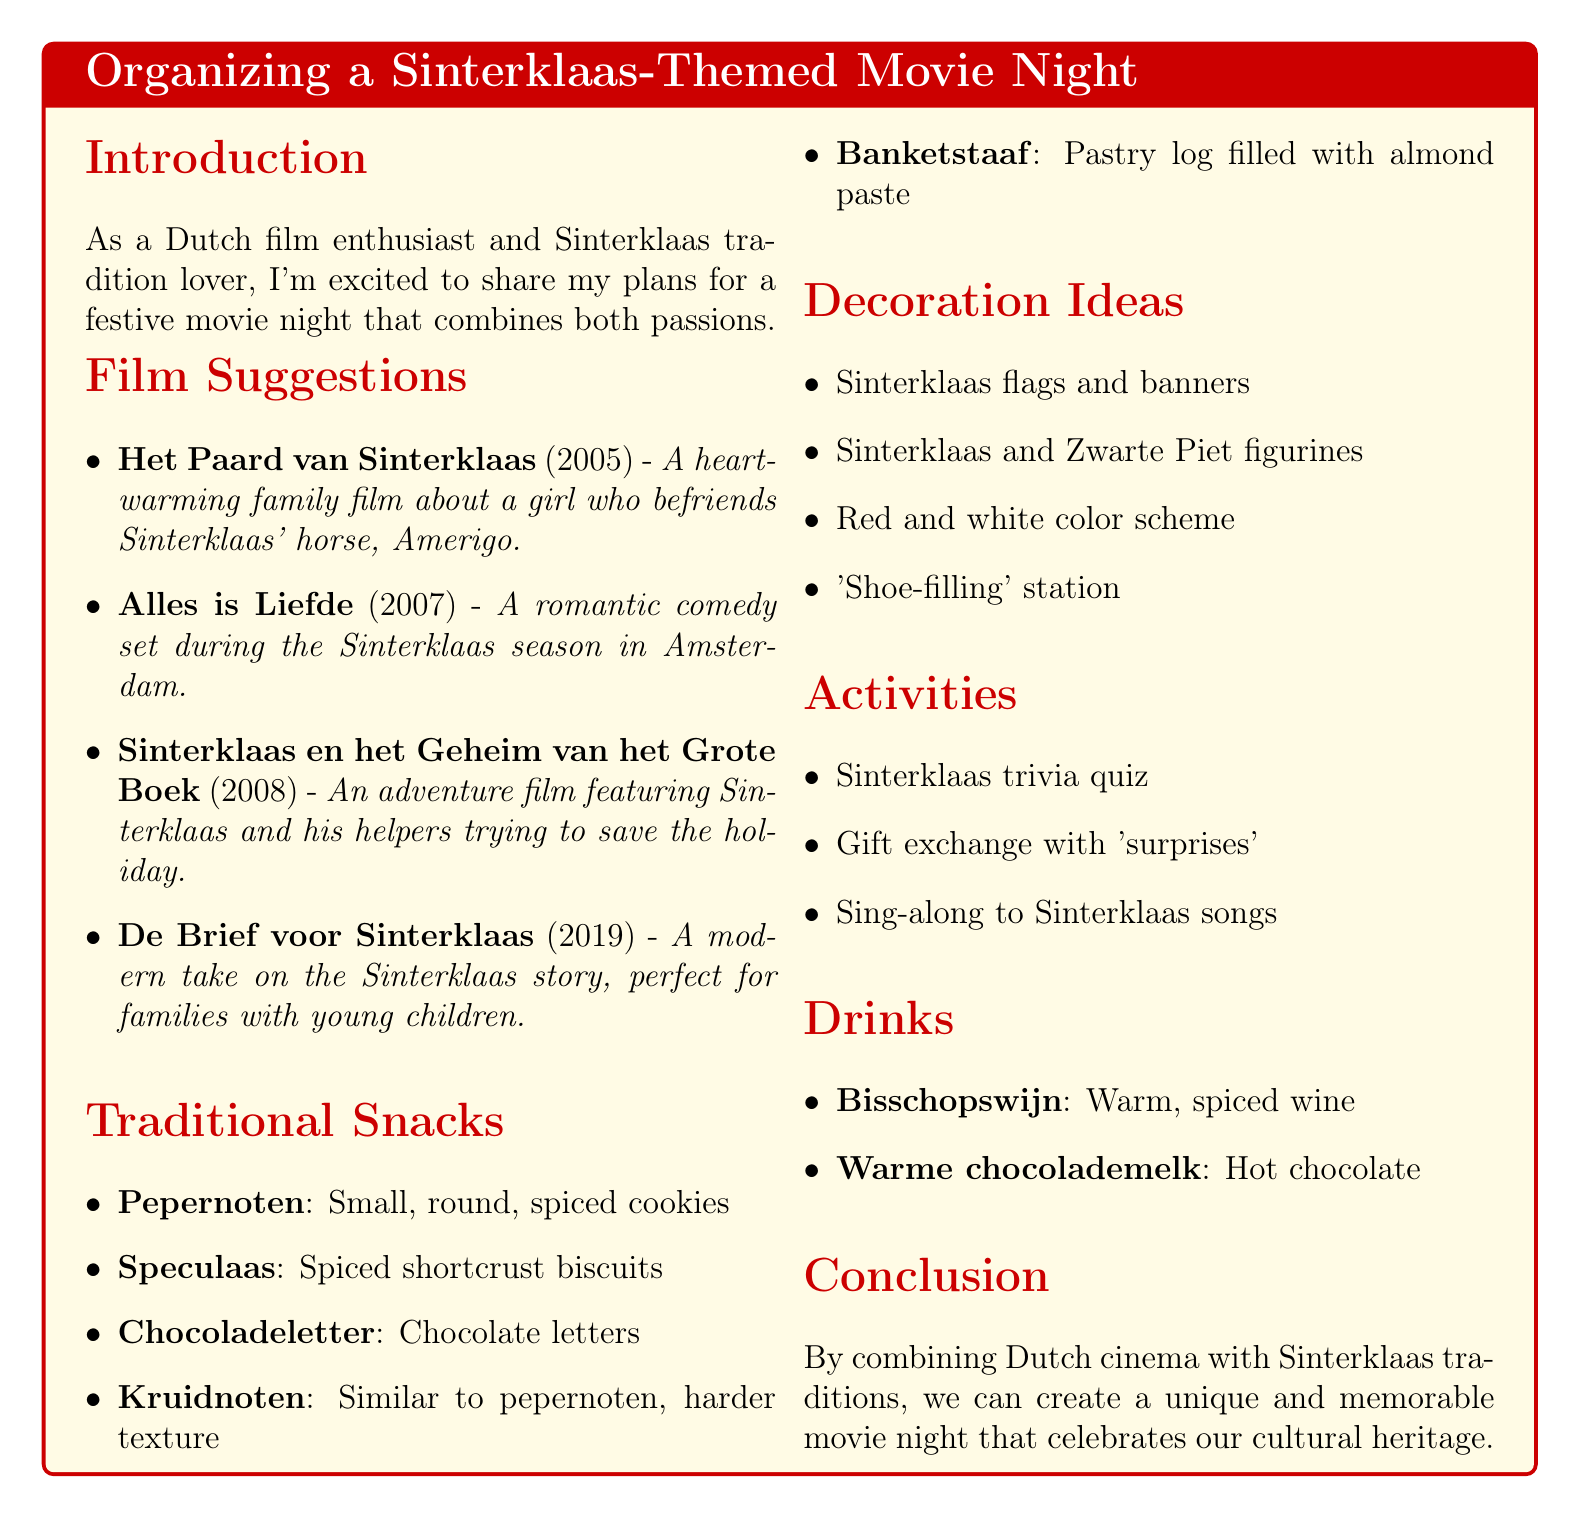What is the title of the memo? The title of the memo is presented at the beginning and captures the main topic of the document.
Answer: Organizing a Sinterklaas-Themed Movie Night Who directed "Het Paard van Sinterklaas"? This information is located in the film suggestions section, detailing the creators of each recommended film.
Answer: Mischa Kamp What year was "Alles is Liefde" released? The year of release is specified in the film suggestions section alongside the corresponding titles.
Answer: 2007 Name one of the traditional snacks listed in the document. The document includes a variety of traditional snacks associated with Sinterklaas, each with a description.
Answer: Pepernoten How many drinks are suggested? The number of drink suggestions can be found in the drinks section of the memo.
Answer: 2 Which film features Sinterklaas trying to save the holiday? By reviewing the descriptions in the film suggestions, one can identify which movie has that particular plot.
Answer: Sinterklaas en het Geheim van het Grote Boek What kind of activity involves a trivia quiz? The activities section outlines engagements that can be included in the movie night, pointing to interactive elements.
Answer: Sinterklaas trivia quiz What should the color scheme for decorations be? The decoration ideas section highlights specific color themes to use, indicating a festive atmosphere.
Answer: Red and white 